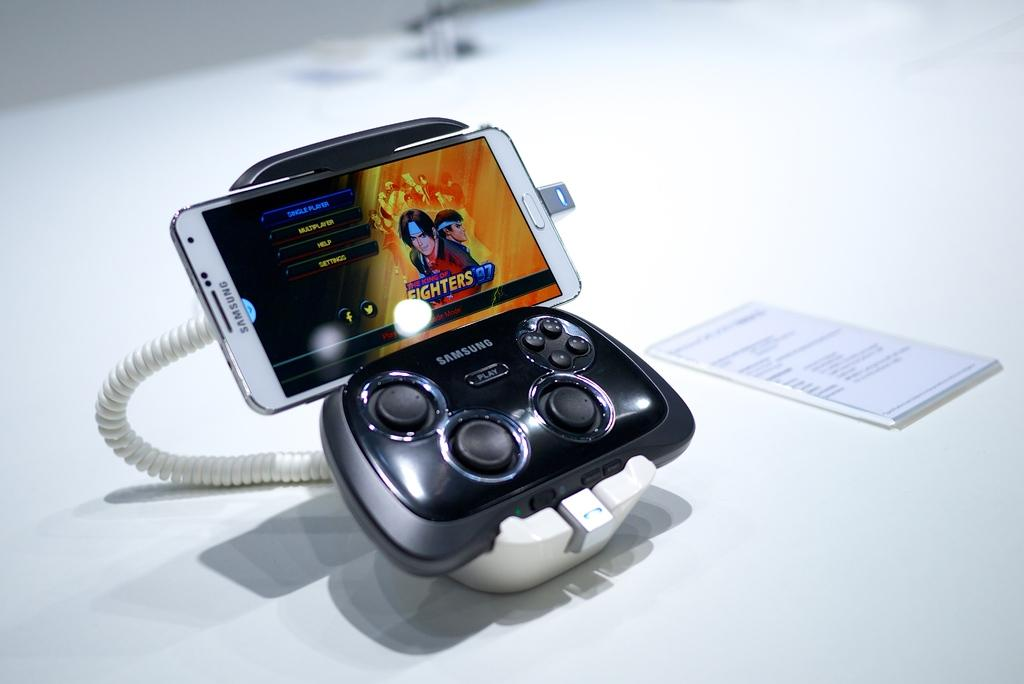<image>
Share a concise interpretation of the image provided. A cellphone connected to a console style controller so the user can play Fighters 97. 